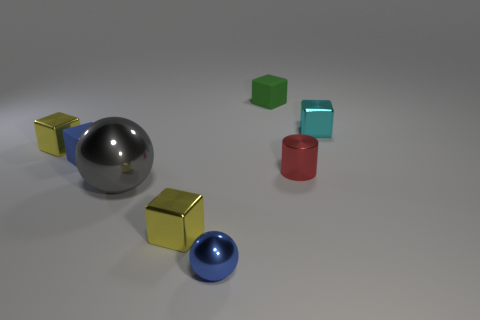Is there a tiny matte object that has the same color as the tiny ball?
Ensure brevity in your answer.  Yes. What size is the block that is the same color as the tiny ball?
Your answer should be compact. Small. Is the tiny block that is on the right side of the tiny green cube made of the same material as the yellow object in front of the tiny red cylinder?
Make the answer very short. Yes. Is there anything else that is the same shape as the small red shiny thing?
Your response must be concise. No. Is the cyan thing made of the same material as the blue thing right of the blue cube?
Keep it short and to the point. Yes. There is a small rubber object that is to the left of the small yellow cube that is in front of the tiny yellow metal object that is left of the big gray thing; what color is it?
Provide a short and direct response. Blue. There is a blue metallic object that is the same size as the red cylinder; what shape is it?
Offer a very short reply. Sphere. Are there any other things that have the same size as the cyan shiny cube?
Keep it short and to the point. Yes. There is a yellow shiny cube that is behind the red cylinder; does it have the same size as the yellow thing in front of the red cylinder?
Provide a short and direct response. Yes. There is a cube that is in front of the small red shiny cylinder; what size is it?
Give a very brief answer. Small. 